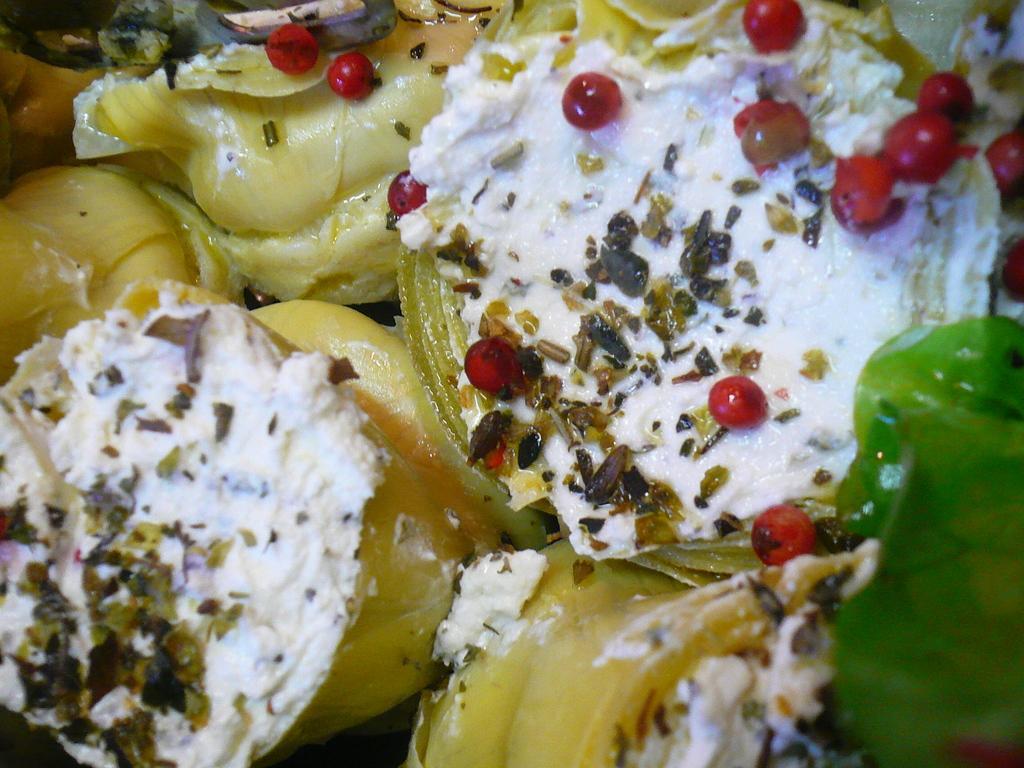In one or two sentences, can you explain what this image depicts? In this image I see the food and I see the white color cream on it and I see the red color things. 